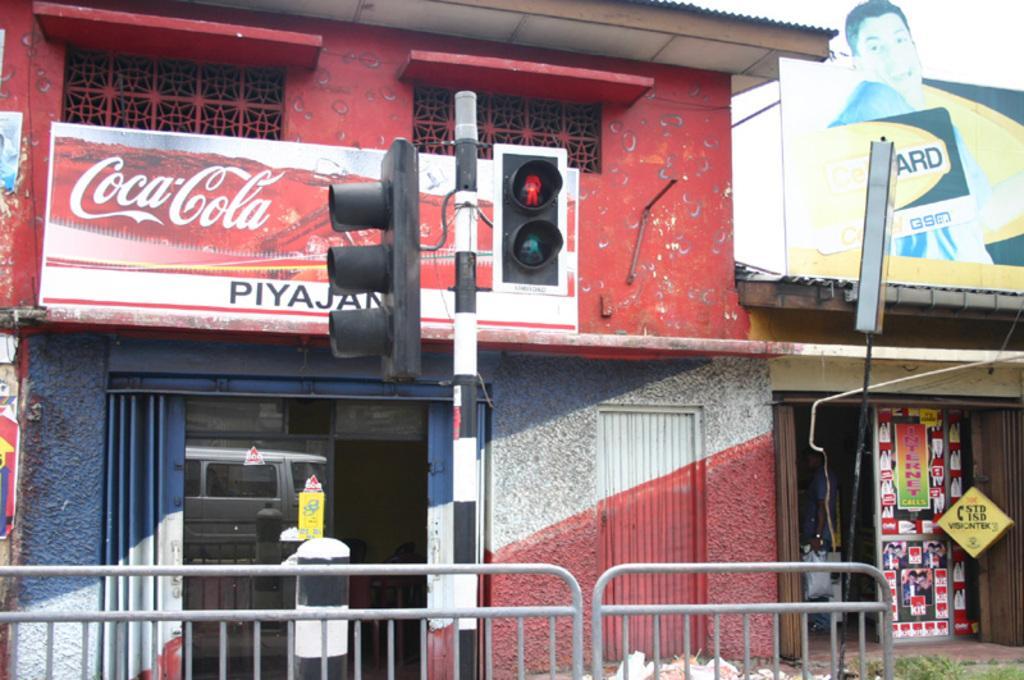In one or two sentences, can you explain what this image depicts? In this picture I can see at the bottom there is a grill. In the middle there are traffic lights, in the background there are shops. On the right side there is a hoarding. 